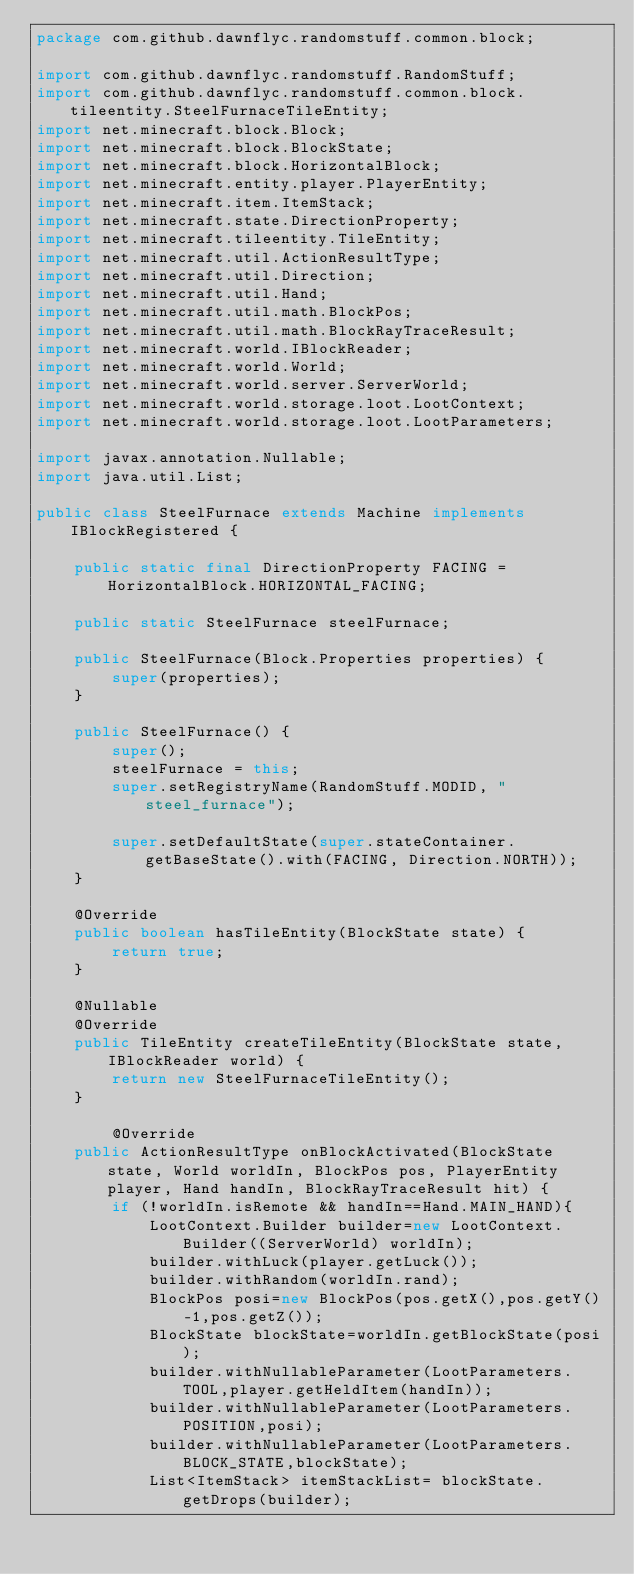<code> <loc_0><loc_0><loc_500><loc_500><_Java_>package com.github.dawnflyc.randomstuff.common.block;

import com.github.dawnflyc.randomstuff.RandomStuff;
import com.github.dawnflyc.randomstuff.common.block.tileentity.SteelFurnaceTileEntity;
import net.minecraft.block.Block;
import net.minecraft.block.BlockState;
import net.minecraft.block.HorizontalBlock;
import net.minecraft.entity.player.PlayerEntity;
import net.minecraft.item.ItemStack;
import net.minecraft.state.DirectionProperty;
import net.minecraft.tileentity.TileEntity;
import net.minecraft.util.ActionResultType;
import net.minecraft.util.Direction;
import net.minecraft.util.Hand;
import net.minecraft.util.math.BlockPos;
import net.minecraft.util.math.BlockRayTraceResult;
import net.minecraft.world.IBlockReader;
import net.minecraft.world.World;
import net.minecraft.world.server.ServerWorld;
import net.minecraft.world.storage.loot.LootContext;
import net.minecraft.world.storage.loot.LootParameters;

import javax.annotation.Nullable;
import java.util.List;

public class SteelFurnace extends Machine implements IBlockRegistered {

    public static final DirectionProperty FACING = HorizontalBlock.HORIZONTAL_FACING;

    public static SteelFurnace steelFurnace;

    public SteelFurnace(Block.Properties properties) {
        super(properties);
    }

    public SteelFurnace() {
        super();
        steelFurnace = this;
        super.setRegistryName(RandomStuff.MODID, "steel_furnace");

        super.setDefaultState(super.stateContainer.getBaseState().with(FACING, Direction.NORTH));
    }

    @Override
    public boolean hasTileEntity(BlockState state) {
        return true;
    }

    @Nullable
    @Override
    public TileEntity createTileEntity(BlockState state, IBlockReader world) {
        return new SteelFurnaceTileEntity();
    }

        @Override
    public ActionResultType onBlockActivated(BlockState state, World worldIn, BlockPos pos, PlayerEntity player, Hand handIn, BlockRayTraceResult hit) {
        if (!worldIn.isRemote && handIn==Hand.MAIN_HAND){
            LootContext.Builder builder=new LootContext.Builder((ServerWorld) worldIn);
            builder.withLuck(player.getLuck());
            builder.withRandom(worldIn.rand);
            BlockPos posi=new BlockPos(pos.getX(),pos.getY()-1,pos.getZ());
            BlockState blockState=worldIn.getBlockState(posi);
            builder.withNullableParameter(LootParameters.TOOL,player.getHeldItem(handIn));
            builder.withNullableParameter(LootParameters.POSITION,posi);
            builder.withNullableParameter(LootParameters.BLOCK_STATE,blockState);
            List<ItemStack> itemStackList= blockState.getDrops(builder);</code> 